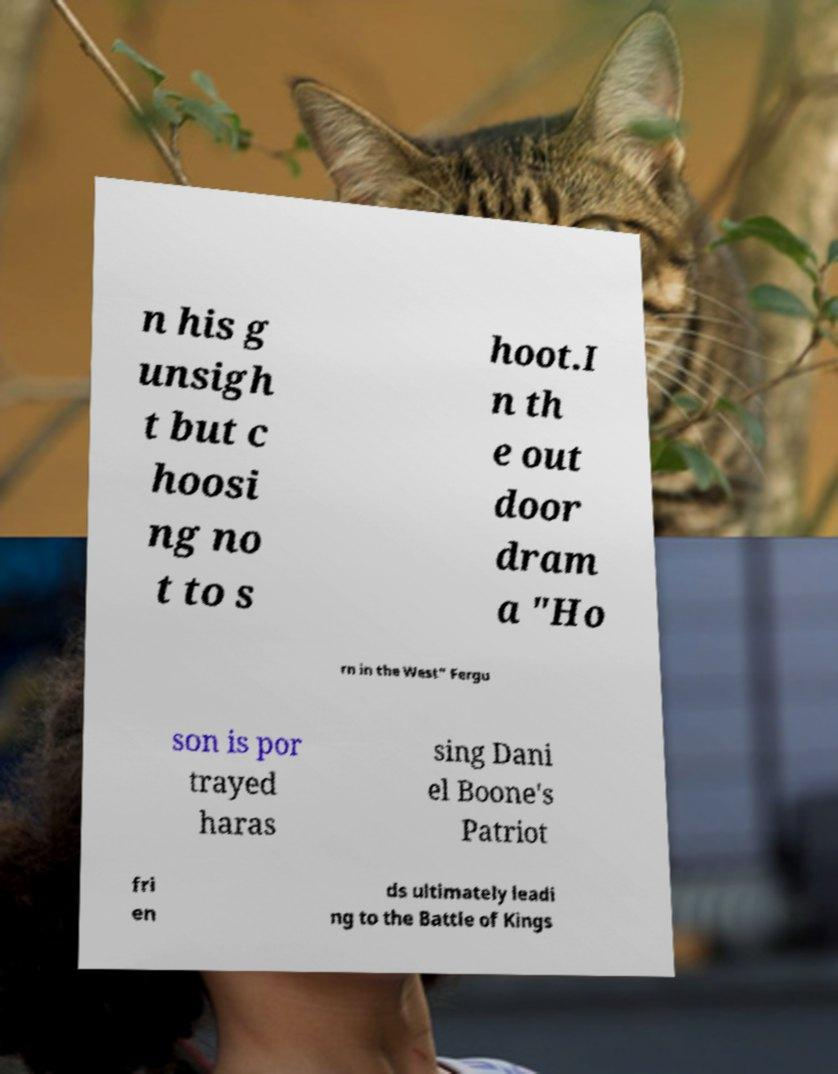Please identify and transcribe the text found in this image. n his g unsigh t but c hoosi ng no t to s hoot.I n th e out door dram a "Ho rn in the West" Fergu son is por trayed haras sing Dani el Boone's Patriot fri en ds ultimately leadi ng to the Battle of Kings 